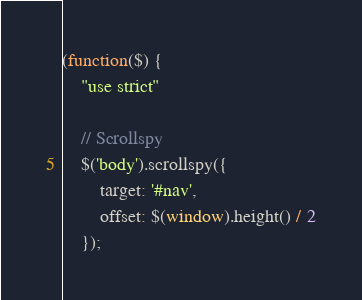Convert code to text. <code><loc_0><loc_0><loc_500><loc_500><_JavaScript_>(function($) {
	"use strict"

	// Scrollspy
	$('body').scrollspy({
		target: '#nav',
		offset: $(window).height() / 2
	});
</code> 